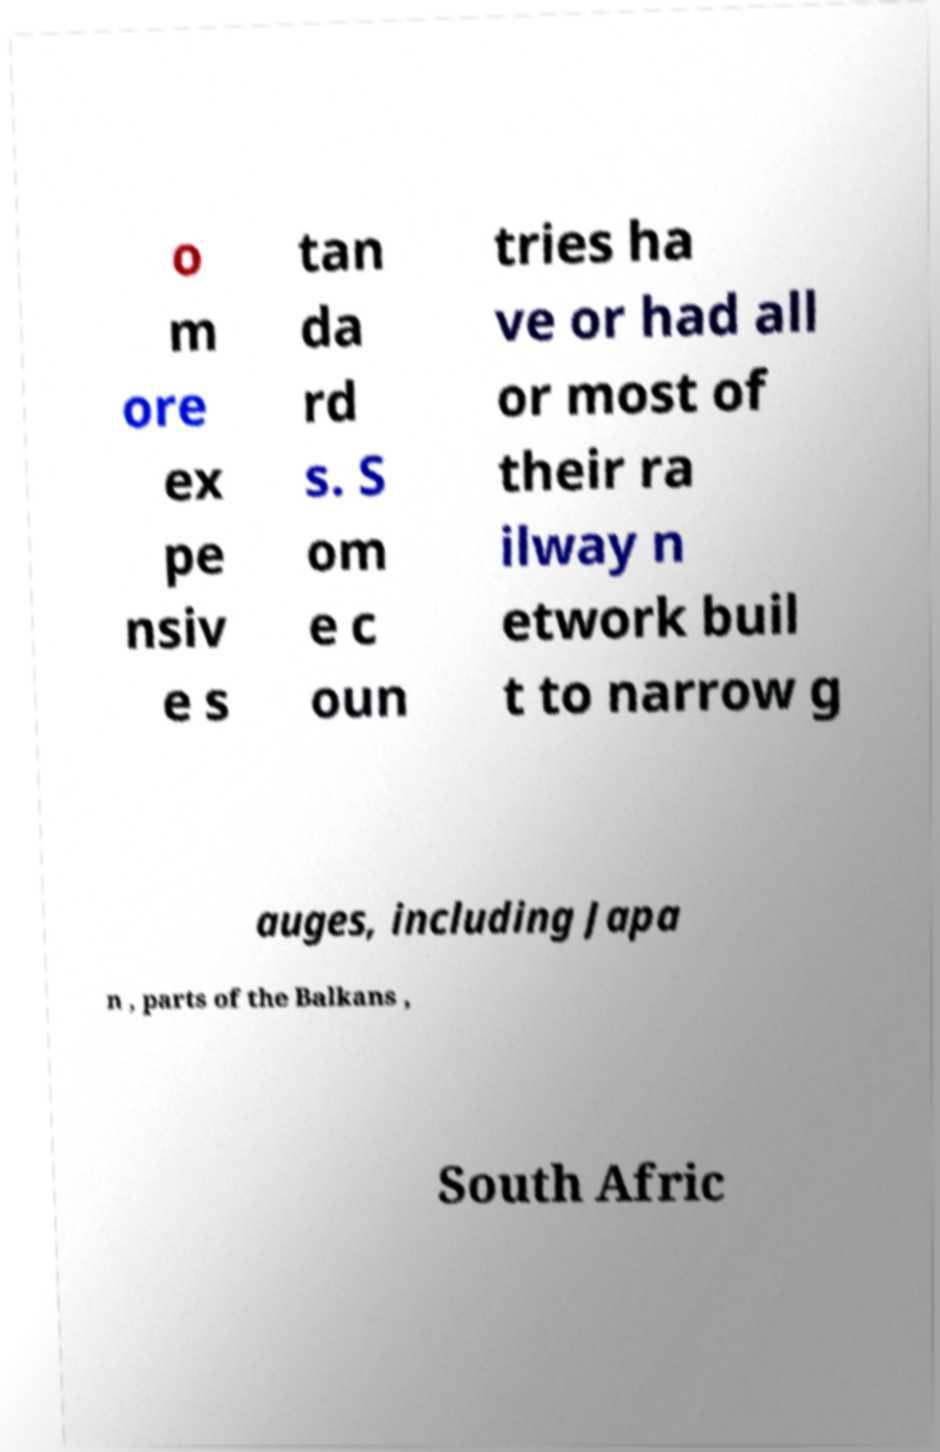Can you read and provide the text displayed in the image?This photo seems to have some interesting text. Can you extract and type it out for me? o m ore ex pe nsiv e s tan da rd s. S om e c oun tries ha ve or had all or most of their ra ilway n etwork buil t to narrow g auges, including Japa n , parts of the Balkans , South Afric 